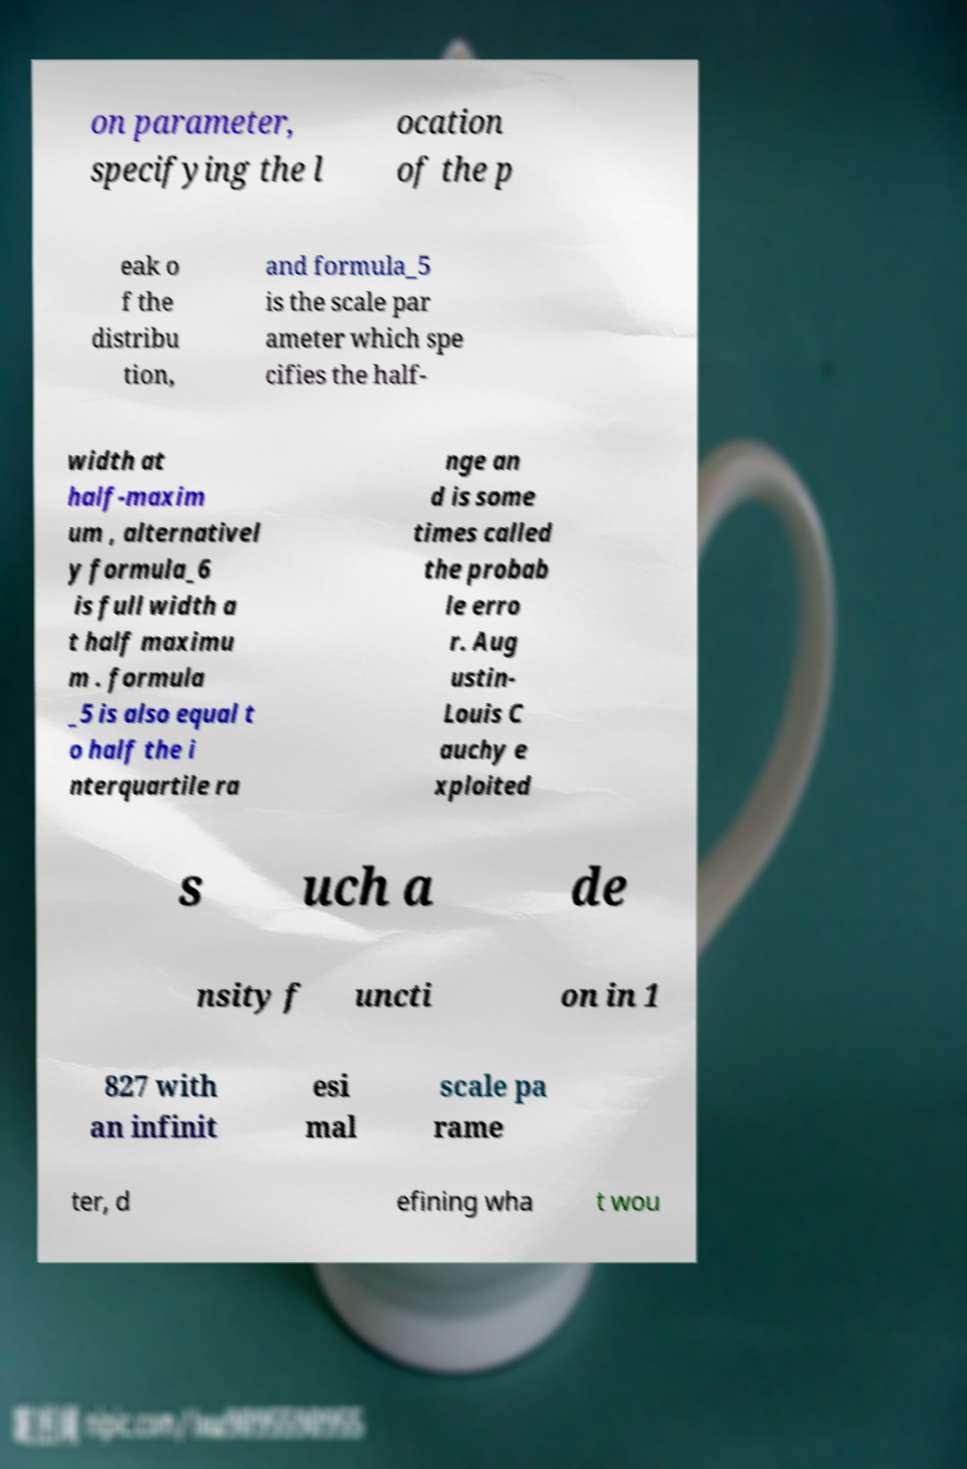For documentation purposes, I need the text within this image transcribed. Could you provide that? on parameter, specifying the l ocation of the p eak o f the distribu tion, and formula_5 is the scale par ameter which spe cifies the half- width at half-maxim um , alternativel y formula_6 is full width a t half maximu m . formula _5 is also equal t o half the i nterquartile ra nge an d is some times called the probab le erro r. Aug ustin- Louis C auchy e xploited s uch a de nsity f uncti on in 1 827 with an infinit esi mal scale pa rame ter, d efining wha t wou 